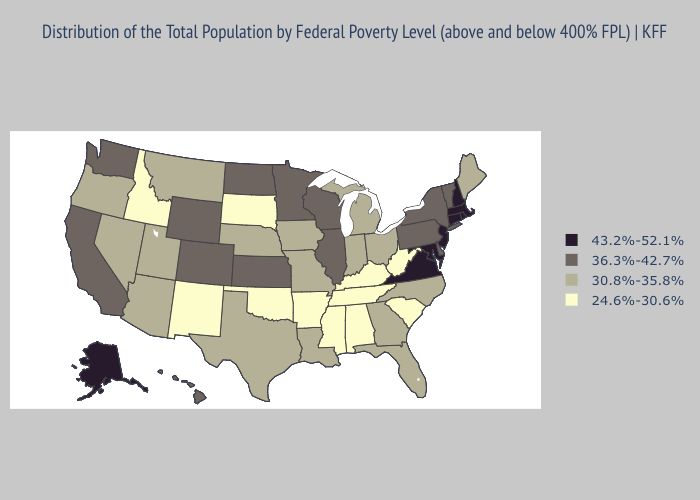What is the lowest value in the South?
Answer briefly. 24.6%-30.6%. Does Kentucky have a higher value than Maryland?
Answer briefly. No. Name the states that have a value in the range 24.6%-30.6%?
Write a very short answer. Alabama, Arkansas, Idaho, Kentucky, Mississippi, New Mexico, Oklahoma, South Carolina, South Dakota, Tennessee, West Virginia. What is the value of Indiana?
Write a very short answer. 30.8%-35.8%. Does Massachusetts have a higher value than Alaska?
Quick response, please. No. Name the states that have a value in the range 43.2%-52.1%?
Answer briefly. Alaska, Connecticut, Maryland, Massachusetts, New Hampshire, New Jersey, Rhode Island, Virginia. Name the states that have a value in the range 24.6%-30.6%?
Write a very short answer. Alabama, Arkansas, Idaho, Kentucky, Mississippi, New Mexico, Oklahoma, South Carolina, South Dakota, Tennessee, West Virginia. What is the value of Nevada?
Quick response, please. 30.8%-35.8%. Among the states that border Colorado , does New Mexico have the highest value?
Answer briefly. No. What is the highest value in the USA?
Give a very brief answer. 43.2%-52.1%. What is the lowest value in the West?
Be succinct. 24.6%-30.6%. Name the states that have a value in the range 43.2%-52.1%?
Keep it brief. Alaska, Connecticut, Maryland, Massachusetts, New Hampshire, New Jersey, Rhode Island, Virginia. Name the states that have a value in the range 43.2%-52.1%?
Keep it brief. Alaska, Connecticut, Maryland, Massachusetts, New Hampshire, New Jersey, Rhode Island, Virginia. Name the states that have a value in the range 24.6%-30.6%?
Give a very brief answer. Alabama, Arkansas, Idaho, Kentucky, Mississippi, New Mexico, Oklahoma, South Carolina, South Dakota, Tennessee, West Virginia. What is the value of Kentucky?
Give a very brief answer. 24.6%-30.6%. 